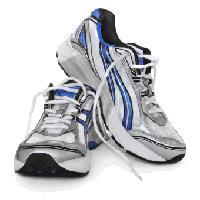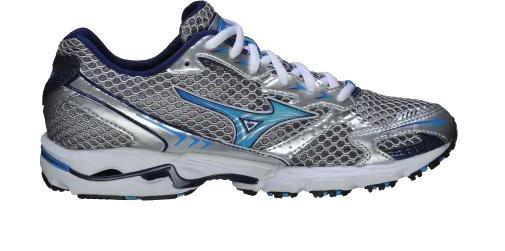The first image is the image on the left, the second image is the image on the right. Considering the images on both sides, is "One image shows a pair of sneakers and the other image features a single right-facing sneaker, and all sneakers feature some shade of blue somewhere." valid? Answer yes or no. Yes. The first image is the image on the left, the second image is the image on the right. Considering the images on both sides, is "The right image contains exactly one shoe." valid? Answer yes or no. Yes. 